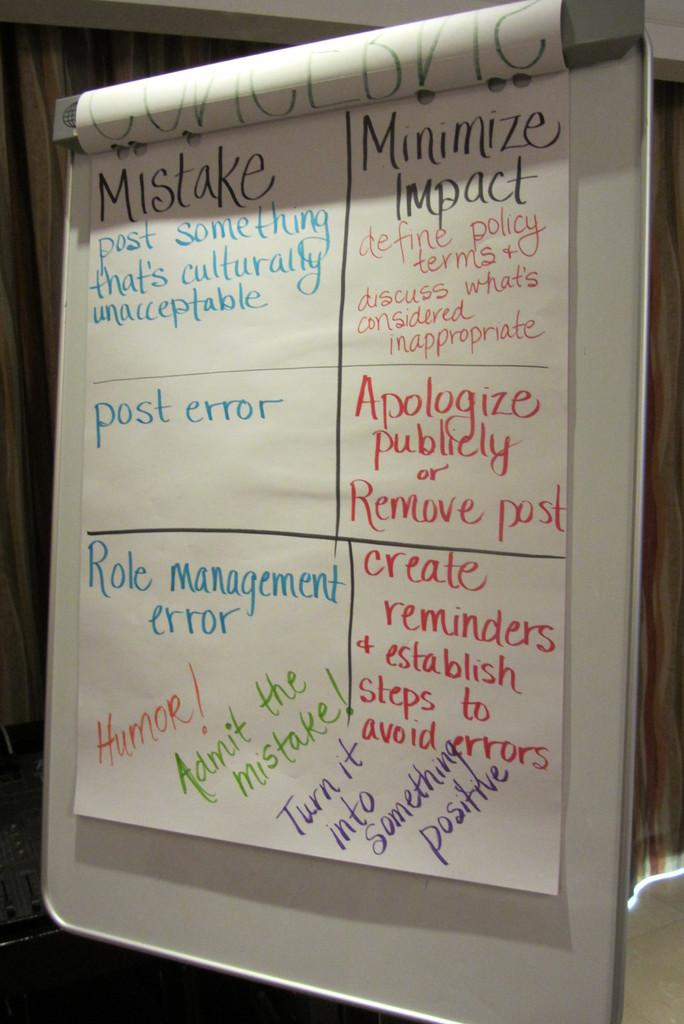<image>
Render a clear and concise summary of the photo. A presentation board has a page divided into sections regarding mistakes, apologies, and minimising impacts 